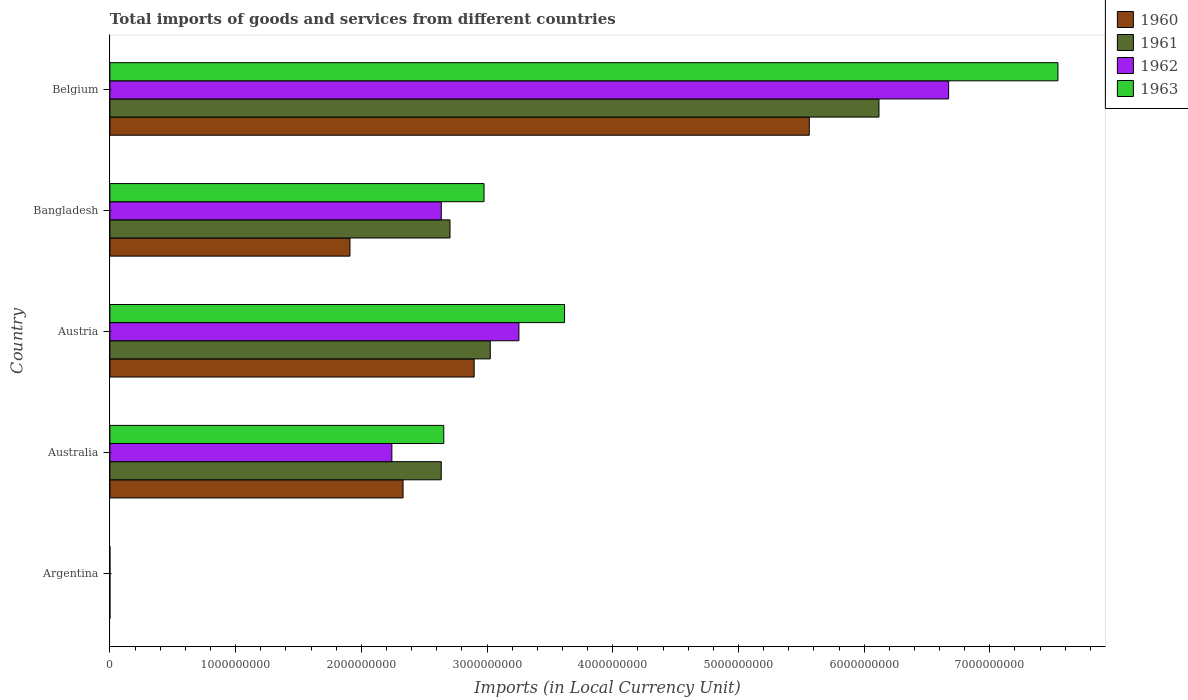How many different coloured bars are there?
Keep it short and to the point. 4. How many groups of bars are there?
Provide a short and direct response. 5. Are the number of bars per tick equal to the number of legend labels?
Ensure brevity in your answer.  Yes. What is the Amount of goods and services imports in 1962 in Belgium?
Provide a short and direct response. 6.67e+09. Across all countries, what is the maximum Amount of goods and services imports in 1963?
Offer a terse response. 7.54e+09. Across all countries, what is the minimum Amount of goods and services imports in 1961?
Ensure brevity in your answer.  0.01. In which country was the Amount of goods and services imports in 1962 maximum?
Your answer should be very brief. Belgium. What is the total Amount of goods and services imports in 1961 in the graph?
Your answer should be very brief. 1.45e+1. What is the difference between the Amount of goods and services imports in 1962 in Argentina and that in Austria?
Your answer should be compact. -3.25e+09. What is the difference between the Amount of goods and services imports in 1961 in Australia and the Amount of goods and services imports in 1962 in Belgium?
Offer a very short reply. -4.04e+09. What is the average Amount of goods and services imports in 1960 per country?
Offer a terse response. 2.54e+09. What is the difference between the Amount of goods and services imports in 1961 and Amount of goods and services imports in 1963 in Bangladesh?
Give a very brief answer. -2.71e+08. In how many countries, is the Amount of goods and services imports in 1961 greater than 4400000000 LCU?
Offer a terse response. 1. What is the ratio of the Amount of goods and services imports in 1963 in Australia to that in Austria?
Your answer should be very brief. 0.73. Is the Amount of goods and services imports in 1962 in Bangladesh less than that in Belgium?
Your answer should be compact. Yes. Is the difference between the Amount of goods and services imports in 1961 in Austria and Belgium greater than the difference between the Amount of goods and services imports in 1963 in Austria and Belgium?
Your response must be concise. Yes. What is the difference between the highest and the second highest Amount of goods and services imports in 1963?
Offer a terse response. 3.93e+09. What is the difference between the highest and the lowest Amount of goods and services imports in 1962?
Give a very brief answer. 6.67e+09. In how many countries, is the Amount of goods and services imports in 1961 greater than the average Amount of goods and services imports in 1961 taken over all countries?
Ensure brevity in your answer.  2. What does the 1st bar from the top in Australia represents?
Offer a very short reply. 1963. What does the 1st bar from the bottom in Austria represents?
Your answer should be very brief. 1960. Is it the case that in every country, the sum of the Amount of goods and services imports in 1962 and Amount of goods and services imports in 1960 is greater than the Amount of goods and services imports in 1963?
Ensure brevity in your answer.  Yes. How many countries are there in the graph?
Ensure brevity in your answer.  5. Are the values on the major ticks of X-axis written in scientific E-notation?
Make the answer very short. No. Does the graph contain any zero values?
Provide a short and direct response. No. Where does the legend appear in the graph?
Provide a short and direct response. Top right. How are the legend labels stacked?
Offer a very short reply. Vertical. What is the title of the graph?
Provide a short and direct response. Total imports of goods and services from different countries. Does "1981" appear as one of the legend labels in the graph?
Give a very brief answer. No. What is the label or title of the X-axis?
Offer a very short reply. Imports (in Local Currency Unit). What is the label or title of the Y-axis?
Provide a succinct answer. Country. What is the Imports (in Local Currency Unit) in 1960 in Argentina?
Provide a short and direct response. 0.01. What is the Imports (in Local Currency Unit) of 1961 in Argentina?
Ensure brevity in your answer.  0.01. What is the Imports (in Local Currency Unit) in 1962 in Argentina?
Your response must be concise. 0.02. What is the Imports (in Local Currency Unit) of 1963 in Argentina?
Ensure brevity in your answer.  0.02. What is the Imports (in Local Currency Unit) in 1960 in Australia?
Provide a succinct answer. 2.33e+09. What is the Imports (in Local Currency Unit) of 1961 in Australia?
Your response must be concise. 2.64e+09. What is the Imports (in Local Currency Unit) in 1962 in Australia?
Provide a succinct answer. 2.24e+09. What is the Imports (in Local Currency Unit) in 1963 in Australia?
Provide a short and direct response. 2.66e+09. What is the Imports (in Local Currency Unit) of 1960 in Austria?
Ensure brevity in your answer.  2.90e+09. What is the Imports (in Local Currency Unit) in 1961 in Austria?
Give a very brief answer. 3.03e+09. What is the Imports (in Local Currency Unit) in 1962 in Austria?
Keep it short and to the point. 3.25e+09. What is the Imports (in Local Currency Unit) of 1963 in Austria?
Offer a very short reply. 3.62e+09. What is the Imports (in Local Currency Unit) in 1960 in Bangladesh?
Your response must be concise. 1.91e+09. What is the Imports (in Local Currency Unit) of 1961 in Bangladesh?
Offer a very short reply. 2.71e+09. What is the Imports (in Local Currency Unit) of 1962 in Bangladesh?
Give a very brief answer. 2.64e+09. What is the Imports (in Local Currency Unit) of 1963 in Bangladesh?
Give a very brief answer. 2.98e+09. What is the Imports (in Local Currency Unit) in 1960 in Belgium?
Provide a succinct answer. 5.56e+09. What is the Imports (in Local Currency Unit) in 1961 in Belgium?
Make the answer very short. 6.12e+09. What is the Imports (in Local Currency Unit) of 1962 in Belgium?
Your answer should be very brief. 6.67e+09. What is the Imports (in Local Currency Unit) of 1963 in Belgium?
Keep it short and to the point. 7.54e+09. Across all countries, what is the maximum Imports (in Local Currency Unit) of 1960?
Make the answer very short. 5.56e+09. Across all countries, what is the maximum Imports (in Local Currency Unit) of 1961?
Provide a short and direct response. 6.12e+09. Across all countries, what is the maximum Imports (in Local Currency Unit) in 1962?
Give a very brief answer. 6.67e+09. Across all countries, what is the maximum Imports (in Local Currency Unit) of 1963?
Your answer should be compact. 7.54e+09. Across all countries, what is the minimum Imports (in Local Currency Unit) in 1960?
Provide a succinct answer. 0.01. Across all countries, what is the minimum Imports (in Local Currency Unit) of 1961?
Your answer should be very brief. 0.01. Across all countries, what is the minimum Imports (in Local Currency Unit) in 1962?
Give a very brief answer. 0.02. Across all countries, what is the minimum Imports (in Local Currency Unit) of 1963?
Offer a very short reply. 0.02. What is the total Imports (in Local Currency Unit) in 1960 in the graph?
Give a very brief answer. 1.27e+1. What is the total Imports (in Local Currency Unit) of 1961 in the graph?
Give a very brief answer. 1.45e+1. What is the total Imports (in Local Currency Unit) in 1962 in the graph?
Offer a very short reply. 1.48e+1. What is the total Imports (in Local Currency Unit) in 1963 in the graph?
Make the answer very short. 1.68e+1. What is the difference between the Imports (in Local Currency Unit) of 1960 in Argentina and that in Australia?
Ensure brevity in your answer.  -2.33e+09. What is the difference between the Imports (in Local Currency Unit) in 1961 in Argentina and that in Australia?
Provide a short and direct response. -2.64e+09. What is the difference between the Imports (in Local Currency Unit) in 1962 in Argentina and that in Australia?
Offer a very short reply. -2.24e+09. What is the difference between the Imports (in Local Currency Unit) of 1963 in Argentina and that in Australia?
Make the answer very short. -2.66e+09. What is the difference between the Imports (in Local Currency Unit) of 1960 in Argentina and that in Austria?
Keep it short and to the point. -2.90e+09. What is the difference between the Imports (in Local Currency Unit) in 1961 in Argentina and that in Austria?
Provide a succinct answer. -3.03e+09. What is the difference between the Imports (in Local Currency Unit) of 1962 in Argentina and that in Austria?
Ensure brevity in your answer.  -3.25e+09. What is the difference between the Imports (in Local Currency Unit) of 1963 in Argentina and that in Austria?
Offer a very short reply. -3.62e+09. What is the difference between the Imports (in Local Currency Unit) in 1960 in Argentina and that in Bangladesh?
Make the answer very short. -1.91e+09. What is the difference between the Imports (in Local Currency Unit) in 1961 in Argentina and that in Bangladesh?
Provide a short and direct response. -2.71e+09. What is the difference between the Imports (in Local Currency Unit) in 1962 in Argentina and that in Bangladesh?
Give a very brief answer. -2.64e+09. What is the difference between the Imports (in Local Currency Unit) in 1963 in Argentina and that in Bangladesh?
Your response must be concise. -2.98e+09. What is the difference between the Imports (in Local Currency Unit) in 1960 in Argentina and that in Belgium?
Keep it short and to the point. -5.56e+09. What is the difference between the Imports (in Local Currency Unit) in 1961 in Argentina and that in Belgium?
Make the answer very short. -6.12e+09. What is the difference between the Imports (in Local Currency Unit) of 1962 in Argentina and that in Belgium?
Provide a short and direct response. -6.67e+09. What is the difference between the Imports (in Local Currency Unit) of 1963 in Argentina and that in Belgium?
Your answer should be compact. -7.54e+09. What is the difference between the Imports (in Local Currency Unit) in 1960 in Australia and that in Austria?
Your response must be concise. -5.66e+08. What is the difference between the Imports (in Local Currency Unit) of 1961 in Australia and that in Austria?
Ensure brevity in your answer.  -3.90e+08. What is the difference between the Imports (in Local Currency Unit) of 1962 in Australia and that in Austria?
Offer a terse response. -1.01e+09. What is the difference between the Imports (in Local Currency Unit) of 1963 in Australia and that in Austria?
Provide a short and direct response. -9.61e+08. What is the difference between the Imports (in Local Currency Unit) of 1960 in Australia and that in Bangladesh?
Make the answer very short. 4.22e+08. What is the difference between the Imports (in Local Currency Unit) in 1961 in Australia and that in Bangladesh?
Provide a succinct answer. -6.96e+07. What is the difference between the Imports (in Local Currency Unit) of 1962 in Australia and that in Bangladesh?
Your answer should be compact. -3.93e+08. What is the difference between the Imports (in Local Currency Unit) in 1963 in Australia and that in Bangladesh?
Your answer should be compact. -3.20e+08. What is the difference between the Imports (in Local Currency Unit) in 1960 in Australia and that in Belgium?
Your answer should be compact. -3.23e+09. What is the difference between the Imports (in Local Currency Unit) of 1961 in Australia and that in Belgium?
Keep it short and to the point. -3.48e+09. What is the difference between the Imports (in Local Currency Unit) of 1962 in Australia and that in Belgium?
Give a very brief answer. -4.43e+09. What is the difference between the Imports (in Local Currency Unit) of 1963 in Australia and that in Belgium?
Give a very brief answer. -4.89e+09. What is the difference between the Imports (in Local Currency Unit) in 1960 in Austria and that in Bangladesh?
Ensure brevity in your answer.  9.88e+08. What is the difference between the Imports (in Local Currency Unit) in 1961 in Austria and that in Bangladesh?
Make the answer very short. 3.20e+08. What is the difference between the Imports (in Local Currency Unit) in 1962 in Austria and that in Bangladesh?
Offer a very short reply. 6.18e+08. What is the difference between the Imports (in Local Currency Unit) in 1963 in Austria and that in Bangladesh?
Offer a terse response. 6.41e+08. What is the difference between the Imports (in Local Currency Unit) in 1960 in Austria and that in Belgium?
Give a very brief answer. -2.67e+09. What is the difference between the Imports (in Local Currency Unit) of 1961 in Austria and that in Belgium?
Make the answer very short. -3.09e+09. What is the difference between the Imports (in Local Currency Unit) of 1962 in Austria and that in Belgium?
Your answer should be compact. -3.42e+09. What is the difference between the Imports (in Local Currency Unit) in 1963 in Austria and that in Belgium?
Make the answer very short. -3.93e+09. What is the difference between the Imports (in Local Currency Unit) of 1960 in Bangladesh and that in Belgium?
Ensure brevity in your answer.  -3.65e+09. What is the difference between the Imports (in Local Currency Unit) in 1961 in Bangladesh and that in Belgium?
Give a very brief answer. -3.41e+09. What is the difference between the Imports (in Local Currency Unit) in 1962 in Bangladesh and that in Belgium?
Give a very brief answer. -4.04e+09. What is the difference between the Imports (in Local Currency Unit) in 1963 in Bangladesh and that in Belgium?
Make the answer very short. -4.57e+09. What is the difference between the Imports (in Local Currency Unit) in 1960 in Argentina and the Imports (in Local Currency Unit) in 1961 in Australia?
Provide a succinct answer. -2.64e+09. What is the difference between the Imports (in Local Currency Unit) of 1960 in Argentina and the Imports (in Local Currency Unit) of 1962 in Australia?
Your answer should be very brief. -2.24e+09. What is the difference between the Imports (in Local Currency Unit) in 1960 in Argentina and the Imports (in Local Currency Unit) in 1963 in Australia?
Provide a succinct answer. -2.66e+09. What is the difference between the Imports (in Local Currency Unit) in 1961 in Argentina and the Imports (in Local Currency Unit) in 1962 in Australia?
Your response must be concise. -2.24e+09. What is the difference between the Imports (in Local Currency Unit) of 1961 in Argentina and the Imports (in Local Currency Unit) of 1963 in Australia?
Offer a terse response. -2.66e+09. What is the difference between the Imports (in Local Currency Unit) of 1962 in Argentina and the Imports (in Local Currency Unit) of 1963 in Australia?
Provide a short and direct response. -2.66e+09. What is the difference between the Imports (in Local Currency Unit) of 1960 in Argentina and the Imports (in Local Currency Unit) of 1961 in Austria?
Make the answer very short. -3.03e+09. What is the difference between the Imports (in Local Currency Unit) in 1960 in Argentina and the Imports (in Local Currency Unit) in 1962 in Austria?
Provide a succinct answer. -3.25e+09. What is the difference between the Imports (in Local Currency Unit) in 1960 in Argentina and the Imports (in Local Currency Unit) in 1963 in Austria?
Offer a very short reply. -3.62e+09. What is the difference between the Imports (in Local Currency Unit) in 1961 in Argentina and the Imports (in Local Currency Unit) in 1962 in Austria?
Provide a succinct answer. -3.25e+09. What is the difference between the Imports (in Local Currency Unit) of 1961 in Argentina and the Imports (in Local Currency Unit) of 1963 in Austria?
Your response must be concise. -3.62e+09. What is the difference between the Imports (in Local Currency Unit) in 1962 in Argentina and the Imports (in Local Currency Unit) in 1963 in Austria?
Offer a very short reply. -3.62e+09. What is the difference between the Imports (in Local Currency Unit) in 1960 in Argentina and the Imports (in Local Currency Unit) in 1961 in Bangladesh?
Your answer should be compact. -2.71e+09. What is the difference between the Imports (in Local Currency Unit) of 1960 in Argentina and the Imports (in Local Currency Unit) of 1962 in Bangladesh?
Your answer should be very brief. -2.64e+09. What is the difference between the Imports (in Local Currency Unit) in 1960 in Argentina and the Imports (in Local Currency Unit) in 1963 in Bangladesh?
Make the answer very short. -2.98e+09. What is the difference between the Imports (in Local Currency Unit) in 1961 in Argentina and the Imports (in Local Currency Unit) in 1962 in Bangladesh?
Provide a short and direct response. -2.64e+09. What is the difference between the Imports (in Local Currency Unit) of 1961 in Argentina and the Imports (in Local Currency Unit) of 1963 in Bangladesh?
Offer a very short reply. -2.98e+09. What is the difference between the Imports (in Local Currency Unit) of 1962 in Argentina and the Imports (in Local Currency Unit) of 1963 in Bangladesh?
Provide a succinct answer. -2.98e+09. What is the difference between the Imports (in Local Currency Unit) of 1960 in Argentina and the Imports (in Local Currency Unit) of 1961 in Belgium?
Your response must be concise. -6.12e+09. What is the difference between the Imports (in Local Currency Unit) of 1960 in Argentina and the Imports (in Local Currency Unit) of 1962 in Belgium?
Your answer should be very brief. -6.67e+09. What is the difference between the Imports (in Local Currency Unit) of 1960 in Argentina and the Imports (in Local Currency Unit) of 1963 in Belgium?
Ensure brevity in your answer.  -7.54e+09. What is the difference between the Imports (in Local Currency Unit) in 1961 in Argentina and the Imports (in Local Currency Unit) in 1962 in Belgium?
Your response must be concise. -6.67e+09. What is the difference between the Imports (in Local Currency Unit) of 1961 in Argentina and the Imports (in Local Currency Unit) of 1963 in Belgium?
Provide a short and direct response. -7.54e+09. What is the difference between the Imports (in Local Currency Unit) in 1962 in Argentina and the Imports (in Local Currency Unit) in 1963 in Belgium?
Make the answer very short. -7.54e+09. What is the difference between the Imports (in Local Currency Unit) of 1960 in Australia and the Imports (in Local Currency Unit) of 1961 in Austria?
Make the answer very short. -6.94e+08. What is the difference between the Imports (in Local Currency Unit) in 1960 in Australia and the Imports (in Local Currency Unit) in 1962 in Austria?
Ensure brevity in your answer.  -9.22e+08. What is the difference between the Imports (in Local Currency Unit) of 1960 in Australia and the Imports (in Local Currency Unit) of 1963 in Austria?
Give a very brief answer. -1.28e+09. What is the difference between the Imports (in Local Currency Unit) of 1961 in Australia and the Imports (in Local Currency Unit) of 1962 in Austria?
Your answer should be compact. -6.18e+08. What is the difference between the Imports (in Local Currency Unit) of 1961 in Australia and the Imports (in Local Currency Unit) of 1963 in Austria?
Provide a succinct answer. -9.81e+08. What is the difference between the Imports (in Local Currency Unit) in 1962 in Australia and the Imports (in Local Currency Unit) in 1963 in Austria?
Provide a succinct answer. -1.37e+09. What is the difference between the Imports (in Local Currency Unit) of 1960 in Australia and the Imports (in Local Currency Unit) of 1961 in Bangladesh?
Give a very brief answer. -3.74e+08. What is the difference between the Imports (in Local Currency Unit) in 1960 in Australia and the Imports (in Local Currency Unit) in 1962 in Bangladesh?
Offer a very short reply. -3.04e+08. What is the difference between the Imports (in Local Currency Unit) of 1960 in Australia and the Imports (in Local Currency Unit) of 1963 in Bangladesh?
Make the answer very short. -6.44e+08. What is the difference between the Imports (in Local Currency Unit) of 1961 in Australia and the Imports (in Local Currency Unit) of 1962 in Bangladesh?
Offer a terse response. -1.80e+05. What is the difference between the Imports (in Local Currency Unit) of 1961 in Australia and the Imports (in Local Currency Unit) of 1963 in Bangladesh?
Your response must be concise. -3.40e+08. What is the difference between the Imports (in Local Currency Unit) in 1962 in Australia and the Imports (in Local Currency Unit) in 1963 in Bangladesh?
Provide a short and direct response. -7.33e+08. What is the difference between the Imports (in Local Currency Unit) of 1960 in Australia and the Imports (in Local Currency Unit) of 1961 in Belgium?
Give a very brief answer. -3.79e+09. What is the difference between the Imports (in Local Currency Unit) of 1960 in Australia and the Imports (in Local Currency Unit) of 1962 in Belgium?
Offer a very short reply. -4.34e+09. What is the difference between the Imports (in Local Currency Unit) in 1960 in Australia and the Imports (in Local Currency Unit) in 1963 in Belgium?
Make the answer very short. -5.21e+09. What is the difference between the Imports (in Local Currency Unit) of 1961 in Australia and the Imports (in Local Currency Unit) of 1962 in Belgium?
Your answer should be compact. -4.04e+09. What is the difference between the Imports (in Local Currency Unit) of 1961 in Australia and the Imports (in Local Currency Unit) of 1963 in Belgium?
Your answer should be compact. -4.91e+09. What is the difference between the Imports (in Local Currency Unit) of 1962 in Australia and the Imports (in Local Currency Unit) of 1963 in Belgium?
Make the answer very short. -5.30e+09. What is the difference between the Imports (in Local Currency Unit) of 1960 in Austria and the Imports (in Local Currency Unit) of 1961 in Bangladesh?
Give a very brief answer. 1.92e+08. What is the difference between the Imports (in Local Currency Unit) of 1960 in Austria and the Imports (in Local Currency Unit) of 1962 in Bangladesh?
Make the answer very short. 2.62e+08. What is the difference between the Imports (in Local Currency Unit) in 1960 in Austria and the Imports (in Local Currency Unit) in 1963 in Bangladesh?
Offer a terse response. -7.85e+07. What is the difference between the Imports (in Local Currency Unit) of 1961 in Austria and the Imports (in Local Currency Unit) of 1962 in Bangladesh?
Make the answer very short. 3.90e+08. What is the difference between the Imports (in Local Currency Unit) of 1961 in Austria and the Imports (in Local Currency Unit) of 1963 in Bangladesh?
Offer a very short reply. 4.96e+07. What is the difference between the Imports (in Local Currency Unit) of 1962 in Austria and the Imports (in Local Currency Unit) of 1963 in Bangladesh?
Keep it short and to the point. 2.77e+08. What is the difference between the Imports (in Local Currency Unit) in 1960 in Austria and the Imports (in Local Currency Unit) in 1961 in Belgium?
Offer a terse response. -3.22e+09. What is the difference between the Imports (in Local Currency Unit) in 1960 in Austria and the Imports (in Local Currency Unit) in 1962 in Belgium?
Provide a short and direct response. -3.77e+09. What is the difference between the Imports (in Local Currency Unit) of 1960 in Austria and the Imports (in Local Currency Unit) of 1963 in Belgium?
Offer a very short reply. -4.64e+09. What is the difference between the Imports (in Local Currency Unit) of 1961 in Austria and the Imports (in Local Currency Unit) of 1962 in Belgium?
Ensure brevity in your answer.  -3.65e+09. What is the difference between the Imports (in Local Currency Unit) in 1961 in Austria and the Imports (in Local Currency Unit) in 1963 in Belgium?
Provide a short and direct response. -4.52e+09. What is the difference between the Imports (in Local Currency Unit) in 1962 in Austria and the Imports (in Local Currency Unit) in 1963 in Belgium?
Make the answer very short. -4.29e+09. What is the difference between the Imports (in Local Currency Unit) in 1960 in Bangladesh and the Imports (in Local Currency Unit) in 1961 in Belgium?
Your response must be concise. -4.21e+09. What is the difference between the Imports (in Local Currency Unit) in 1960 in Bangladesh and the Imports (in Local Currency Unit) in 1962 in Belgium?
Ensure brevity in your answer.  -4.76e+09. What is the difference between the Imports (in Local Currency Unit) of 1960 in Bangladesh and the Imports (in Local Currency Unit) of 1963 in Belgium?
Your answer should be very brief. -5.63e+09. What is the difference between the Imports (in Local Currency Unit) in 1961 in Bangladesh and the Imports (in Local Currency Unit) in 1962 in Belgium?
Offer a terse response. -3.97e+09. What is the difference between the Imports (in Local Currency Unit) of 1961 in Bangladesh and the Imports (in Local Currency Unit) of 1963 in Belgium?
Keep it short and to the point. -4.84e+09. What is the difference between the Imports (in Local Currency Unit) in 1962 in Bangladesh and the Imports (in Local Currency Unit) in 1963 in Belgium?
Offer a very short reply. -4.91e+09. What is the average Imports (in Local Currency Unit) in 1960 per country?
Your response must be concise. 2.54e+09. What is the average Imports (in Local Currency Unit) of 1961 per country?
Ensure brevity in your answer.  2.90e+09. What is the average Imports (in Local Currency Unit) of 1962 per country?
Your response must be concise. 2.96e+09. What is the average Imports (in Local Currency Unit) of 1963 per country?
Provide a short and direct response. 3.36e+09. What is the difference between the Imports (in Local Currency Unit) of 1960 and Imports (in Local Currency Unit) of 1962 in Argentina?
Offer a very short reply. -0.01. What is the difference between the Imports (in Local Currency Unit) in 1960 and Imports (in Local Currency Unit) in 1963 in Argentina?
Provide a succinct answer. -0.01. What is the difference between the Imports (in Local Currency Unit) of 1961 and Imports (in Local Currency Unit) of 1962 in Argentina?
Your answer should be very brief. -0.01. What is the difference between the Imports (in Local Currency Unit) of 1961 and Imports (in Local Currency Unit) of 1963 in Argentina?
Offer a terse response. -0.01. What is the difference between the Imports (in Local Currency Unit) in 1962 and Imports (in Local Currency Unit) in 1963 in Argentina?
Your response must be concise. 0. What is the difference between the Imports (in Local Currency Unit) of 1960 and Imports (in Local Currency Unit) of 1961 in Australia?
Ensure brevity in your answer.  -3.04e+08. What is the difference between the Imports (in Local Currency Unit) in 1960 and Imports (in Local Currency Unit) in 1962 in Australia?
Keep it short and to the point. 8.90e+07. What is the difference between the Imports (in Local Currency Unit) in 1960 and Imports (in Local Currency Unit) in 1963 in Australia?
Offer a very short reply. -3.24e+08. What is the difference between the Imports (in Local Currency Unit) of 1961 and Imports (in Local Currency Unit) of 1962 in Australia?
Ensure brevity in your answer.  3.93e+08. What is the difference between the Imports (in Local Currency Unit) in 1961 and Imports (in Local Currency Unit) in 1963 in Australia?
Your answer should be very brief. -2.00e+07. What is the difference between the Imports (in Local Currency Unit) of 1962 and Imports (in Local Currency Unit) of 1963 in Australia?
Make the answer very short. -4.13e+08. What is the difference between the Imports (in Local Currency Unit) of 1960 and Imports (in Local Currency Unit) of 1961 in Austria?
Give a very brief answer. -1.28e+08. What is the difference between the Imports (in Local Currency Unit) in 1960 and Imports (in Local Currency Unit) in 1962 in Austria?
Make the answer very short. -3.56e+08. What is the difference between the Imports (in Local Currency Unit) in 1960 and Imports (in Local Currency Unit) in 1963 in Austria?
Keep it short and to the point. -7.19e+08. What is the difference between the Imports (in Local Currency Unit) of 1961 and Imports (in Local Currency Unit) of 1962 in Austria?
Ensure brevity in your answer.  -2.28e+08. What is the difference between the Imports (in Local Currency Unit) of 1961 and Imports (in Local Currency Unit) of 1963 in Austria?
Your response must be concise. -5.91e+08. What is the difference between the Imports (in Local Currency Unit) of 1962 and Imports (in Local Currency Unit) of 1963 in Austria?
Your answer should be very brief. -3.63e+08. What is the difference between the Imports (in Local Currency Unit) in 1960 and Imports (in Local Currency Unit) in 1961 in Bangladesh?
Offer a very short reply. -7.96e+08. What is the difference between the Imports (in Local Currency Unit) of 1960 and Imports (in Local Currency Unit) of 1962 in Bangladesh?
Provide a succinct answer. -7.26e+08. What is the difference between the Imports (in Local Currency Unit) of 1960 and Imports (in Local Currency Unit) of 1963 in Bangladesh?
Keep it short and to the point. -1.07e+09. What is the difference between the Imports (in Local Currency Unit) in 1961 and Imports (in Local Currency Unit) in 1962 in Bangladesh?
Your response must be concise. 6.94e+07. What is the difference between the Imports (in Local Currency Unit) of 1961 and Imports (in Local Currency Unit) of 1963 in Bangladesh?
Provide a short and direct response. -2.71e+08. What is the difference between the Imports (in Local Currency Unit) in 1962 and Imports (in Local Currency Unit) in 1963 in Bangladesh?
Provide a succinct answer. -3.40e+08. What is the difference between the Imports (in Local Currency Unit) of 1960 and Imports (in Local Currency Unit) of 1961 in Belgium?
Offer a terse response. -5.54e+08. What is the difference between the Imports (in Local Currency Unit) of 1960 and Imports (in Local Currency Unit) of 1962 in Belgium?
Give a very brief answer. -1.11e+09. What is the difference between the Imports (in Local Currency Unit) of 1960 and Imports (in Local Currency Unit) of 1963 in Belgium?
Ensure brevity in your answer.  -1.98e+09. What is the difference between the Imports (in Local Currency Unit) of 1961 and Imports (in Local Currency Unit) of 1962 in Belgium?
Provide a short and direct response. -5.54e+08. What is the difference between the Imports (in Local Currency Unit) in 1961 and Imports (in Local Currency Unit) in 1963 in Belgium?
Provide a succinct answer. -1.42e+09. What is the difference between the Imports (in Local Currency Unit) in 1962 and Imports (in Local Currency Unit) in 1963 in Belgium?
Make the answer very short. -8.70e+08. What is the ratio of the Imports (in Local Currency Unit) in 1961 in Argentina to that in Australia?
Offer a terse response. 0. What is the ratio of the Imports (in Local Currency Unit) in 1960 in Argentina to that in Austria?
Make the answer very short. 0. What is the ratio of the Imports (in Local Currency Unit) of 1961 in Argentina to that in Austria?
Offer a terse response. 0. What is the ratio of the Imports (in Local Currency Unit) of 1962 in Argentina to that in Austria?
Provide a succinct answer. 0. What is the ratio of the Imports (in Local Currency Unit) in 1961 in Argentina to that in Bangladesh?
Make the answer very short. 0. What is the ratio of the Imports (in Local Currency Unit) in 1962 in Argentina to that in Bangladesh?
Provide a short and direct response. 0. What is the ratio of the Imports (in Local Currency Unit) of 1963 in Argentina to that in Bangladesh?
Make the answer very short. 0. What is the ratio of the Imports (in Local Currency Unit) in 1960 in Australia to that in Austria?
Provide a succinct answer. 0.8. What is the ratio of the Imports (in Local Currency Unit) of 1961 in Australia to that in Austria?
Offer a terse response. 0.87. What is the ratio of the Imports (in Local Currency Unit) in 1962 in Australia to that in Austria?
Your response must be concise. 0.69. What is the ratio of the Imports (in Local Currency Unit) in 1963 in Australia to that in Austria?
Keep it short and to the point. 0.73. What is the ratio of the Imports (in Local Currency Unit) in 1960 in Australia to that in Bangladesh?
Your answer should be compact. 1.22. What is the ratio of the Imports (in Local Currency Unit) of 1961 in Australia to that in Bangladesh?
Your answer should be very brief. 0.97. What is the ratio of the Imports (in Local Currency Unit) of 1962 in Australia to that in Bangladesh?
Ensure brevity in your answer.  0.85. What is the ratio of the Imports (in Local Currency Unit) in 1963 in Australia to that in Bangladesh?
Give a very brief answer. 0.89. What is the ratio of the Imports (in Local Currency Unit) in 1960 in Australia to that in Belgium?
Provide a short and direct response. 0.42. What is the ratio of the Imports (in Local Currency Unit) in 1961 in Australia to that in Belgium?
Give a very brief answer. 0.43. What is the ratio of the Imports (in Local Currency Unit) of 1962 in Australia to that in Belgium?
Ensure brevity in your answer.  0.34. What is the ratio of the Imports (in Local Currency Unit) in 1963 in Australia to that in Belgium?
Keep it short and to the point. 0.35. What is the ratio of the Imports (in Local Currency Unit) of 1960 in Austria to that in Bangladesh?
Your response must be concise. 1.52. What is the ratio of the Imports (in Local Currency Unit) in 1961 in Austria to that in Bangladesh?
Provide a succinct answer. 1.12. What is the ratio of the Imports (in Local Currency Unit) of 1962 in Austria to that in Bangladesh?
Your answer should be very brief. 1.23. What is the ratio of the Imports (in Local Currency Unit) in 1963 in Austria to that in Bangladesh?
Your response must be concise. 1.22. What is the ratio of the Imports (in Local Currency Unit) of 1960 in Austria to that in Belgium?
Give a very brief answer. 0.52. What is the ratio of the Imports (in Local Currency Unit) in 1961 in Austria to that in Belgium?
Offer a very short reply. 0.49. What is the ratio of the Imports (in Local Currency Unit) of 1962 in Austria to that in Belgium?
Your answer should be very brief. 0.49. What is the ratio of the Imports (in Local Currency Unit) in 1963 in Austria to that in Belgium?
Give a very brief answer. 0.48. What is the ratio of the Imports (in Local Currency Unit) of 1960 in Bangladesh to that in Belgium?
Ensure brevity in your answer.  0.34. What is the ratio of the Imports (in Local Currency Unit) in 1961 in Bangladesh to that in Belgium?
Provide a succinct answer. 0.44. What is the ratio of the Imports (in Local Currency Unit) of 1962 in Bangladesh to that in Belgium?
Ensure brevity in your answer.  0.4. What is the ratio of the Imports (in Local Currency Unit) of 1963 in Bangladesh to that in Belgium?
Provide a short and direct response. 0.39. What is the difference between the highest and the second highest Imports (in Local Currency Unit) in 1960?
Your answer should be compact. 2.67e+09. What is the difference between the highest and the second highest Imports (in Local Currency Unit) in 1961?
Make the answer very short. 3.09e+09. What is the difference between the highest and the second highest Imports (in Local Currency Unit) in 1962?
Keep it short and to the point. 3.42e+09. What is the difference between the highest and the second highest Imports (in Local Currency Unit) of 1963?
Your response must be concise. 3.93e+09. What is the difference between the highest and the lowest Imports (in Local Currency Unit) of 1960?
Provide a succinct answer. 5.56e+09. What is the difference between the highest and the lowest Imports (in Local Currency Unit) in 1961?
Your response must be concise. 6.12e+09. What is the difference between the highest and the lowest Imports (in Local Currency Unit) in 1962?
Your response must be concise. 6.67e+09. What is the difference between the highest and the lowest Imports (in Local Currency Unit) of 1963?
Your response must be concise. 7.54e+09. 